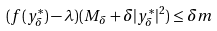<formula> <loc_0><loc_0><loc_500><loc_500>( f ( y ^ { * } _ { \delta } ) - \lambda ) ( M _ { \delta } + \delta | y ^ { * } _ { \delta } | ^ { 2 } ) \leq \delta m</formula> 